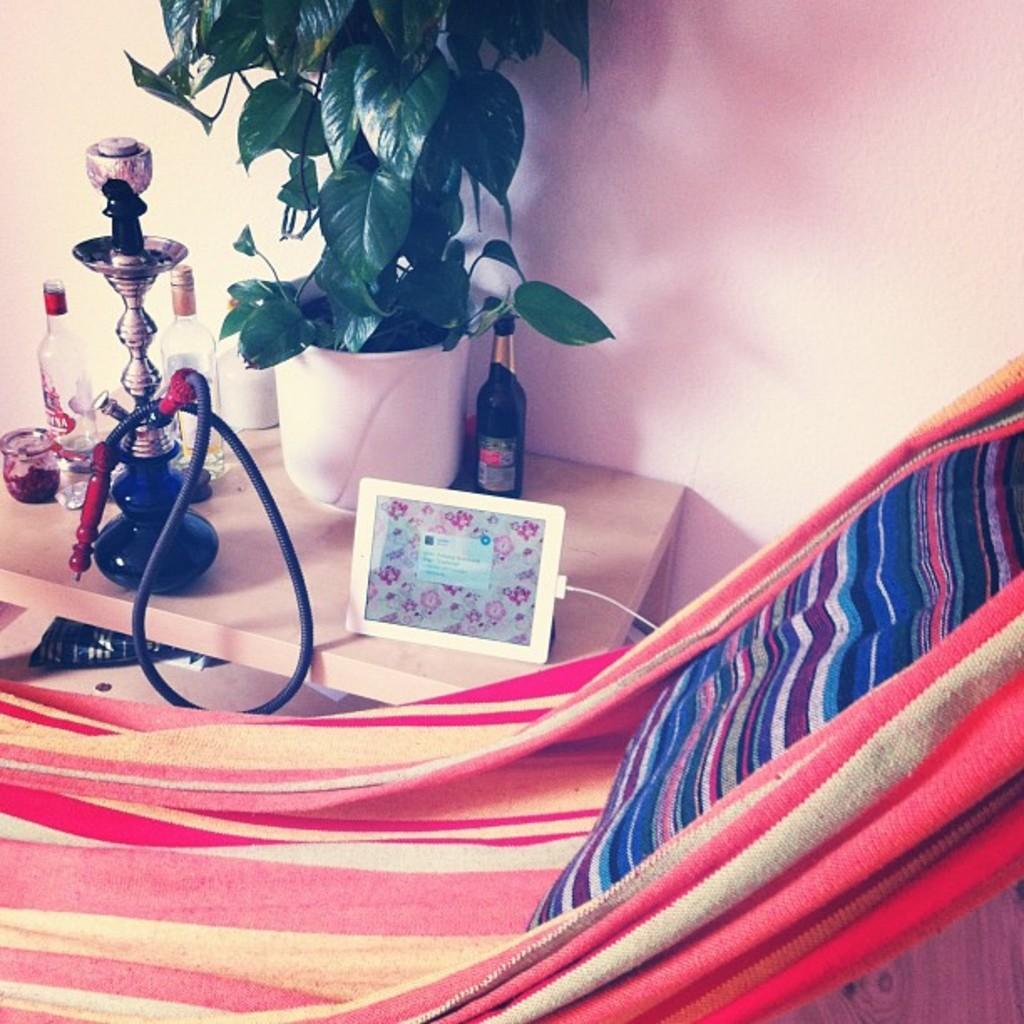Can you describe this image briefly? There is a table on which a hukka pot, vodka bottle and plant were placed along with a i pad. There is a chair here. In the background there is a wall. 